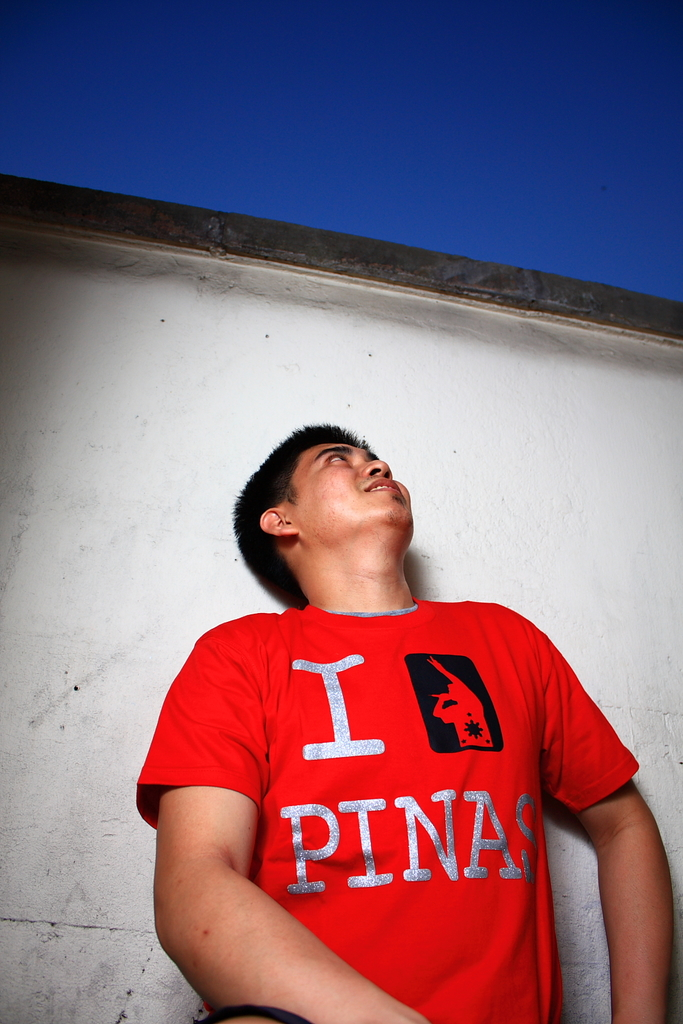What emotions does the man's facial expression suggest? The man's uplifted gaze and slightly open mouth suggest a moment of contemplation or inspiration, possibly reflecting a deep sense of connection or nostalgia. 